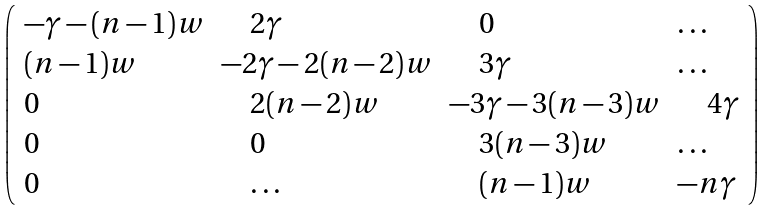<formula> <loc_0><loc_0><loc_500><loc_500>\left ( \begin{array} { l l l l } - \gamma - ( n - 1 ) w & \quad 2 \gamma & \quad 0 & \dots \\ ( n - 1 ) w & - 2 \gamma - 2 ( n - 2 ) w & \quad 3 \gamma & \dots \\ 0 & \quad 2 ( n - 2 ) w & - 3 \gamma - 3 ( n - 3 ) w & \quad 4 \gamma \\ 0 & \quad 0 & \quad 3 ( n - 3 ) w & \dots \\ 0 & \quad \dots & \quad ( n - 1 ) w & - n \gamma \end{array} \right )</formula> 